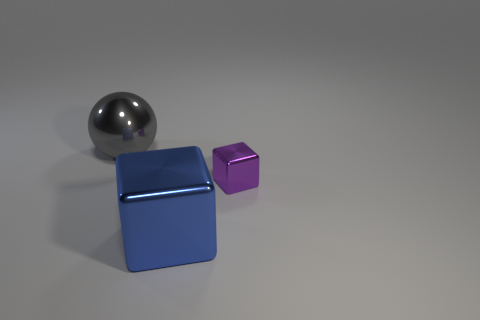Add 1 big red matte objects. How many objects exist? 4 Subtract all balls. How many objects are left? 2 Subtract 1 purple cubes. How many objects are left? 2 Subtract all large green spheres. Subtract all tiny purple cubes. How many objects are left? 2 Add 2 small things. How many small things are left? 3 Add 1 large shiny objects. How many large shiny objects exist? 3 